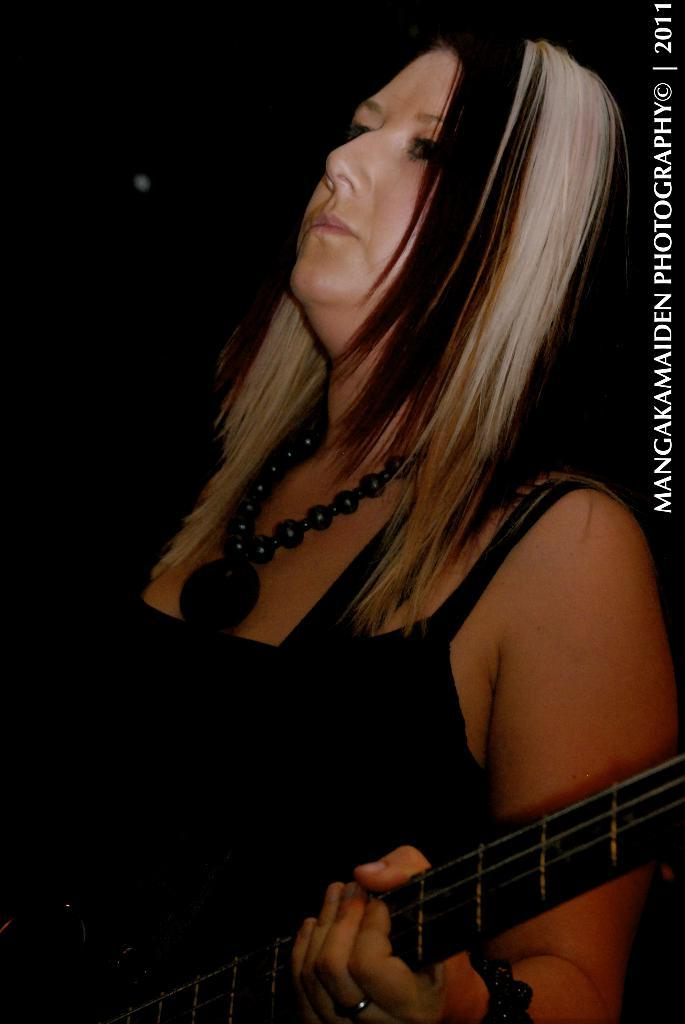Who is present in the image? There is a woman in the image. What is the woman doing in the image? The woman is standing in the image. What object is the woman holding in the image? The woman is holding a guitar in the image. What type of jail can be seen in the background of the image? There is no jail present in the image; it only features a woman standing and holding a guitar. 